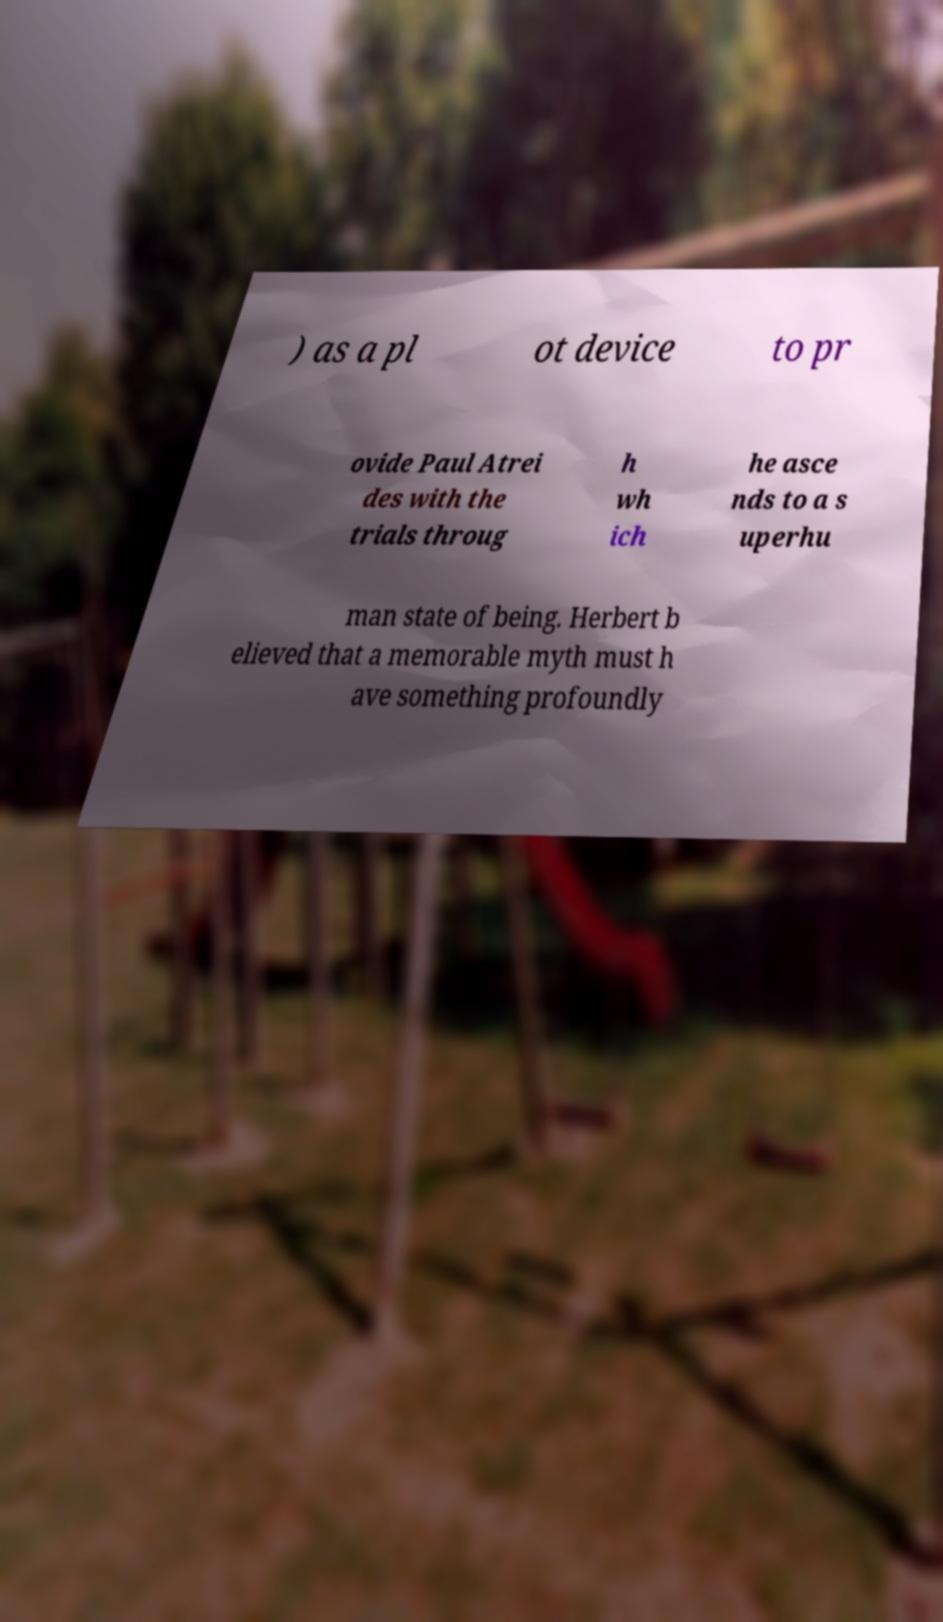Could you assist in decoding the text presented in this image and type it out clearly? ) as a pl ot device to pr ovide Paul Atrei des with the trials throug h wh ich he asce nds to a s uperhu man state of being. Herbert b elieved that a memorable myth must h ave something profoundly 